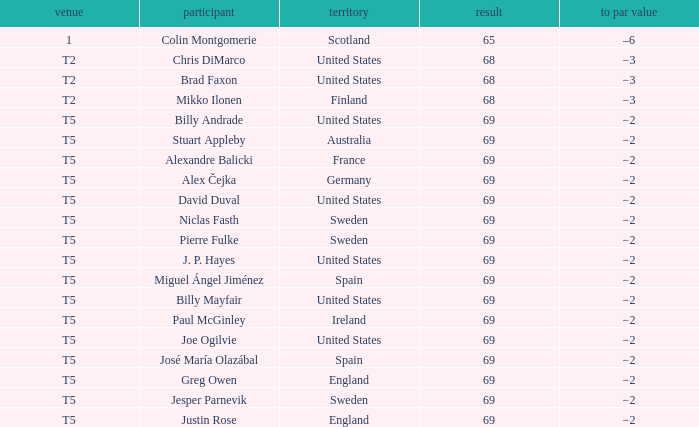What place did Paul McGinley finish in? T5. 